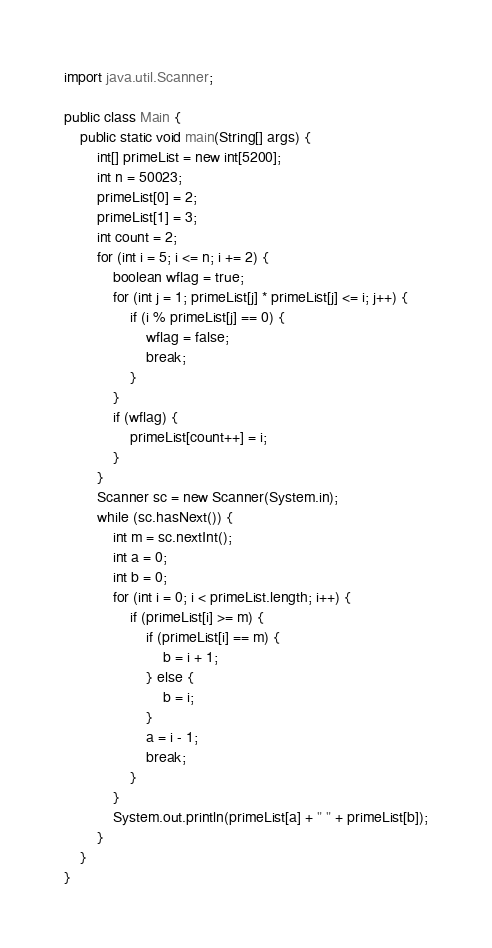<code> <loc_0><loc_0><loc_500><loc_500><_Java_>import java.util.Scanner;

public class Main {
    public static void main(String[] args) {
        int[] primeList = new int[5200];
        int n = 50023;
        primeList[0] = 2;
        primeList[1] = 3;
        int count = 2;
        for (int i = 5; i <= n; i += 2) {
            boolean wflag = true;
            for (int j = 1; primeList[j] * primeList[j] <= i; j++) {
                if (i % primeList[j] == 0) {
                    wflag = false;
                    break;
                }
            }
            if (wflag) {
                primeList[count++] = i;
            }
        }
        Scanner sc = new Scanner(System.in);
        while (sc.hasNext()) {
            int m = sc.nextInt();
            int a = 0;
            int b = 0;
            for (int i = 0; i < primeList.length; i++) {
                if (primeList[i] >= m) {
                    if (primeList[i] == m) {
                        b = i + 1;
                    } else {
                        b = i;
                    }
                    a = i - 1;
                    break;
                }
            }
            System.out.println(primeList[a] + " " + primeList[b]);
        }
    }
}

</code> 